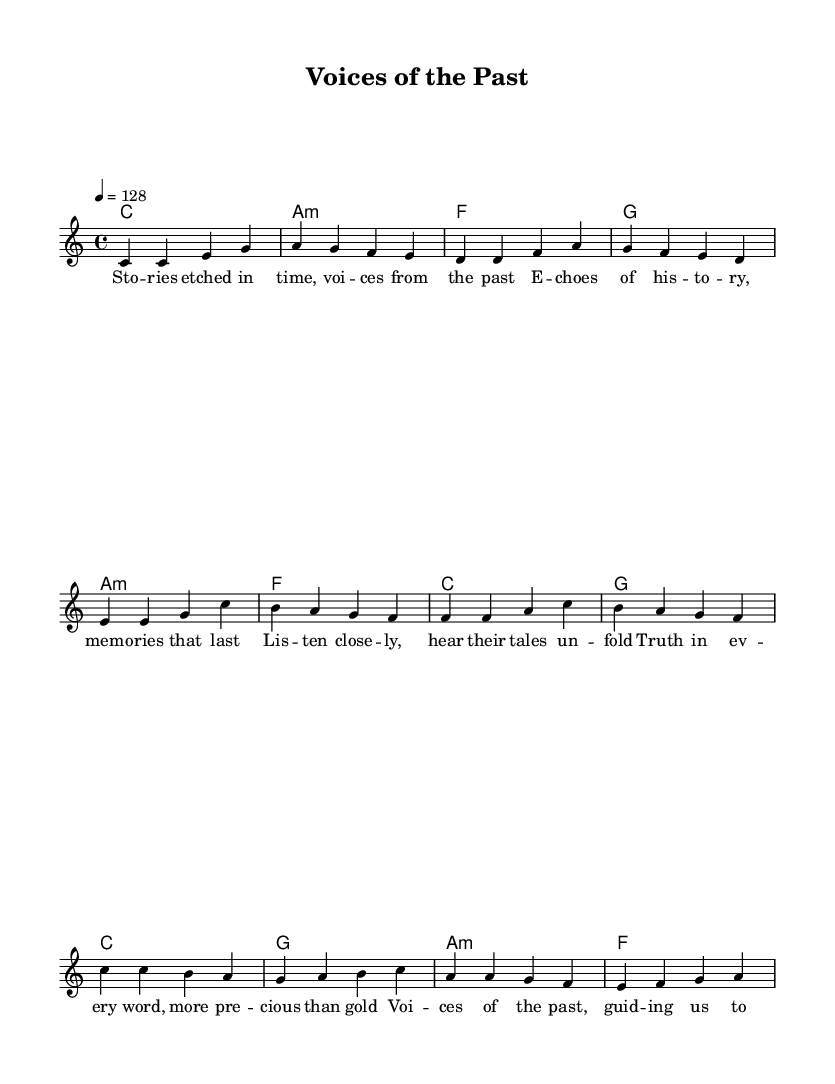What is the key signature of this music? The key signature is C major, which has no sharps or flats.
Answer: C major What is the time signature of the piece? The time signature is indicated at the beginning of the score as 4/4, which means there are four beats per measure.
Answer: 4/4 What is the tempo of the song? The tempo is indicated by the marking of 4 = 128, which translates to a moderately fast pace of 128 beats per minute.
Answer: 128 How many lines are in the verse lyrics? The verse lyrics have six lines, indicating the number of phrases within the verse section of the piece.
Answer: Six What type of harmony is primarily used in the verse section? The harmony in the verse section consists mostly of major and minor chords, specifically C major, A minor, F major, and G major.
Answer: Major and minor chords Which section follows the verse? The pre-chorus section follows directly after the verse, as indicated by the structure of the song.
Answer: Pre-chorus Is the chorus in a higher or lower pitch than the verse? The chorus is presented primarily in a higher pitch (indicated by the use of higher note values and octave notations), suggesting an elevation in musical intensity.
Answer: Higher pitch 